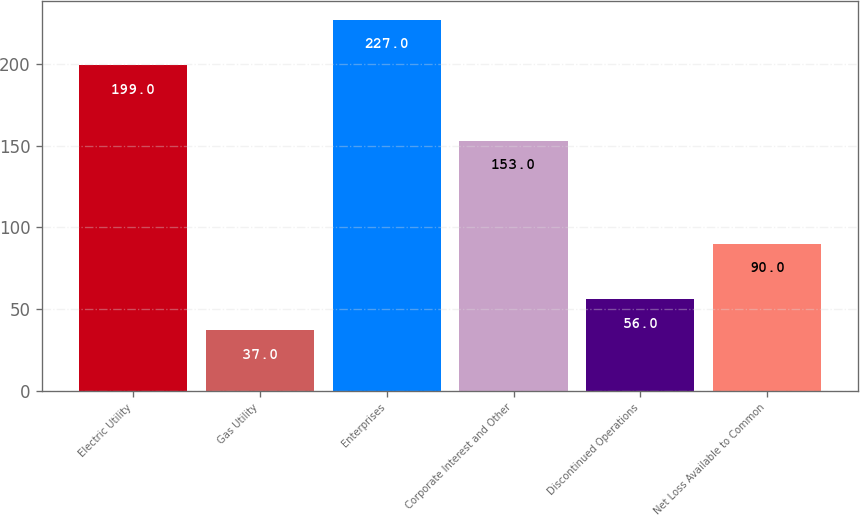Convert chart. <chart><loc_0><loc_0><loc_500><loc_500><bar_chart><fcel>Electric Utility<fcel>Gas Utility<fcel>Enterprises<fcel>Corporate Interest and Other<fcel>Discontinued Operations<fcel>Net Loss Available to Common<nl><fcel>199<fcel>37<fcel>227<fcel>153<fcel>56<fcel>90<nl></chart> 